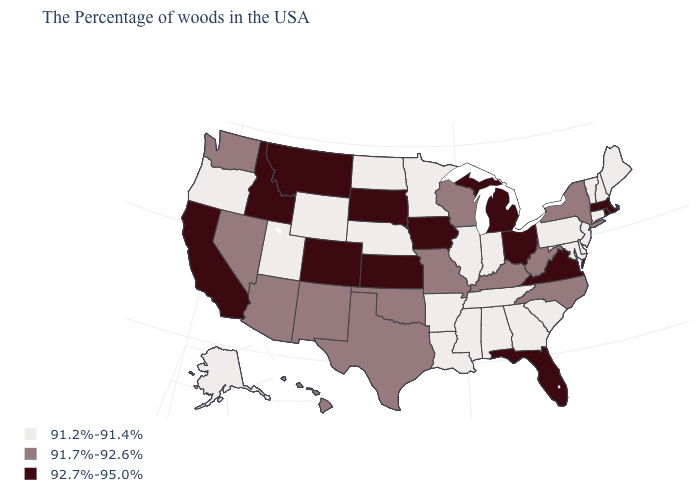Which states have the lowest value in the South?
Concise answer only. Delaware, Maryland, South Carolina, Georgia, Alabama, Tennessee, Mississippi, Louisiana, Arkansas. What is the value of Michigan?
Keep it brief. 92.7%-95.0%. Name the states that have a value in the range 91.2%-91.4%?
Concise answer only. Maine, New Hampshire, Vermont, Connecticut, New Jersey, Delaware, Maryland, Pennsylvania, South Carolina, Georgia, Indiana, Alabama, Tennessee, Illinois, Mississippi, Louisiana, Arkansas, Minnesota, Nebraska, North Dakota, Wyoming, Utah, Oregon, Alaska. What is the value of North Dakota?
Short answer required. 91.2%-91.4%. Does the map have missing data?
Concise answer only. No. What is the value of Georgia?
Quick response, please. 91.2%-91.4%. What is the value of Pennsylvania?
Answer briefly. 91.2%-91.4%. What is the value of New Jersey?
Be succinct. 91.2%-91.4%. What is the value of Hawaii?
Quick response, please. 91.7%-92.6%. Which states have the highest value in the USA?
Write a very short answer. Massachusetts, Rhode Island, Virginia, Ohio, Florida, Michigan, Iowa, Kansas, South Dakota, Colorado, Montana, Idaho, California. Which states have the lowest value in the USA?
Keep it brief. Maine, New Hampshire, Vermont, Connecticut, New Jersey, Delaware, Maryland, Pennsylvania, South Carolina, Georgia, Indiana, Alabama, Tennessee, Illinois, Mississippi, Louisiana, Arkansas, Minnesota, Nebraska, North Dakota, Wyoming, Utah, Oregon, Alaska. How many symbols are there in the legend?
Answer briefly. 3. Name the states that have a value in the range 91.7%-92.6%?
Give a very brief answer. New York, North Carolina, West Virginia, Kentucky, Wisconsin, Missouri, Oklahoma, Texas, New Mexico, Arizona, Nevada, Washington, Hawaii. Among the states that border Washington , does Idaho have the lowest value?
Give a very brief answer. No. What is the value of Alabama?
Quick response, please. 91.2%-91.4%. 